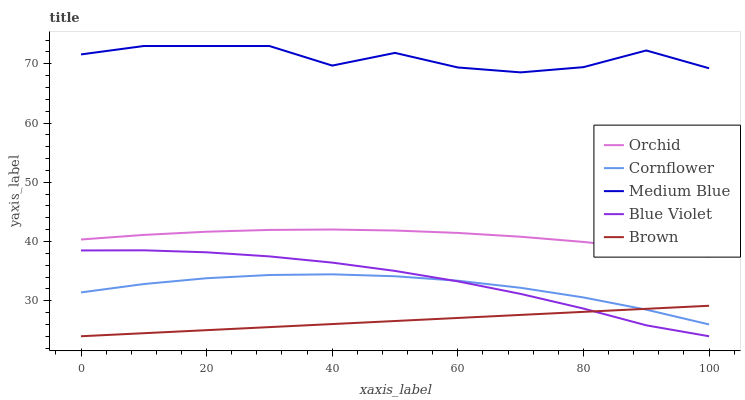Does Brown have the minimum area under the curve?
Answer yes or no. Yes. Does Medium Blue have the maximum area under the curve?
Answer yes or no. Yes. Does Medium Blue have the minimum area under the curve?
Answer yes or no. No. Does Brown have the maximum area under the curve?
Answer yes or no. No. Is Brown the smoothest?
Answer yes or no. Yes. Is Medium Blue the roughest?
Answer yes or no. Yes. Is Medium Blue the smoothest?
Answer yes or no. No. Is Brown the roughest?
Answer yes or no. No. Does Brown have the lowest value?
Answer yes or no. Yes. Does Medium Blue have the lowest value?
Answer yes or no. No. Does Medium Blue have the highest value?
Answer yes or no. Yes. Does Brown have the highest value?
Answer yes or no. No. Is Cornflower less than Orchid?
Answer yes or no. Yes. Is Orchid greater than Brown?
Answer yes or no. Yes. Does Brown intersect Blue Violet?
Answer yes or no. Yes. Is Brown less than Blue Violet?
Answer yes or no. No. Is Brown greater than Blue Violet?
Answer yes or no. No. Does Cornflower intersect Orchid?
Answer yes or no. No. 